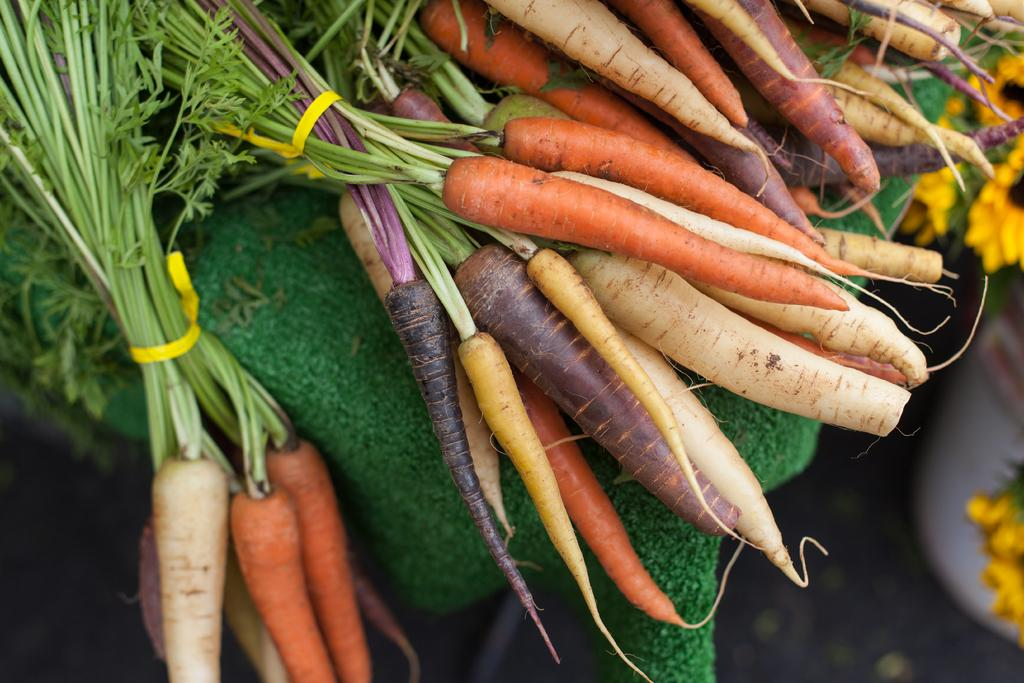What vegetables are on the table in the image? There are carrots and radishes on a table in the image. Can you describe the arrangement of the vegetables on the table? The carrots and radishes are placed on the table. What else is present in the image besides the vegetables? Flowers are present below the table in the image. What type of drain is visible in the image? There is no drain present in the image. How many pets are visible in the image? There are no pets visible in the image. 